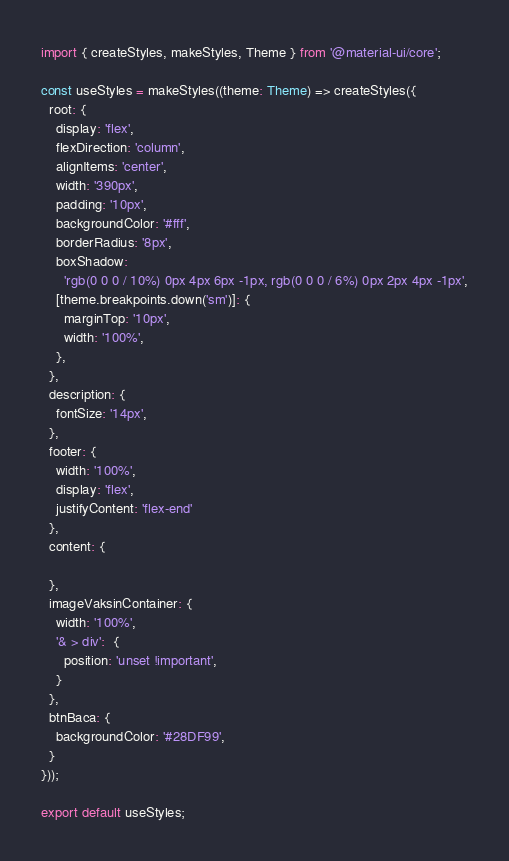Convert code to text. <code><loc_0><loc_0><loc_500><loc_500><_TypeScript_>import { createStyles, makeStyles, Theme } from '@material-ui/core';

const useStyles = makeStyles((theme: Theme) => createStyles({
  root: {
    display: 'flex',
    flexDirection: 'column',
    alignItems: 'center',
    width: '390px',
    padding: '10px',
    backgroundColor: '#fff',
    borderRadius: '8px',
    boxShadow:
      'rgb(0 0 0 / 10%) 0px 4px 6px -1px, rgb(0 0 0 / 6%) 0px 2px 4px -1px',
    [theme.breakpoints.down('sm')]: {
      marginTop: '10px',
      width: '100%',
    },
  },
  description: {
    fontSize: '14px',
  },
  footer: {
    width: '100%',
    display: 'flex',
    justifyContent: 'flex-end'
  },
  content: {

  },
  imageVaksinContainer: {
    width: '100%',
    '& > div':  {
      position: 'unset !important',
    }
  },
  btnBaca: {
    backgroundColor: '#28DF99',    
  }
}));

export default useStyles;</code> 